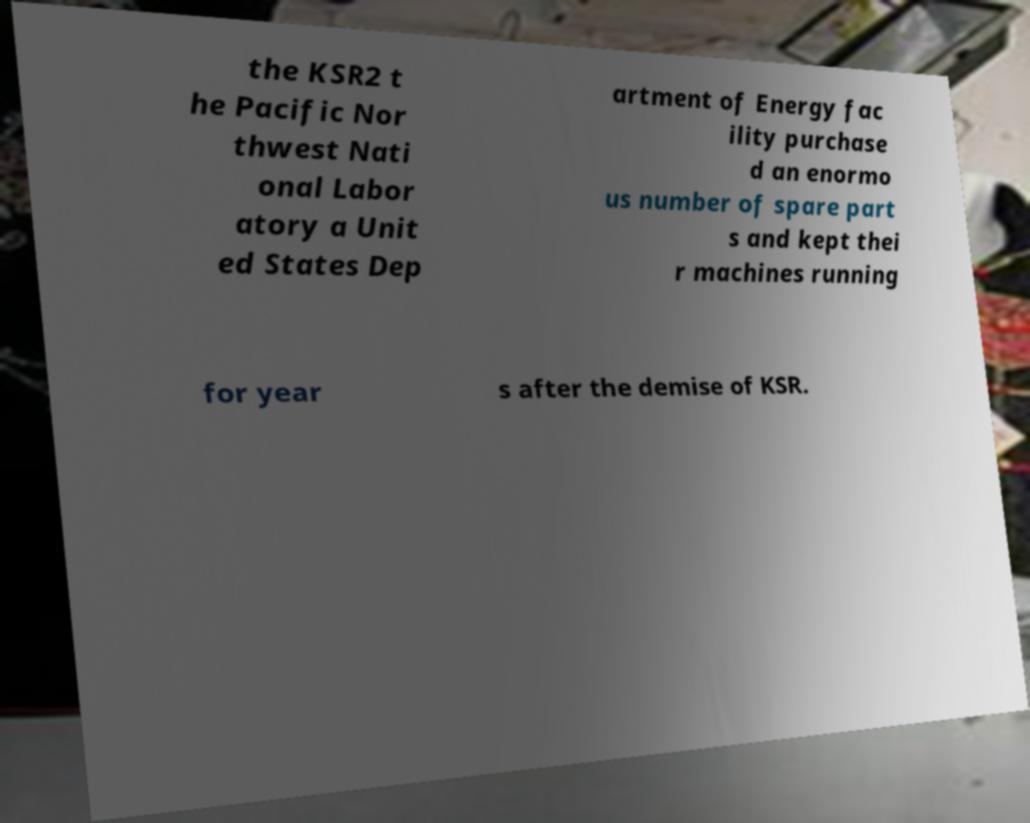Please read and relay the text visible in this image. What does it say? the KSR2 t he Pacific Nor thwest Nati onal Labor atory a Unit ed States Dep artment of Energy fac ility purchase d an enormo us number of spare part s and kept thei r machines running for year s after the demise of KSR. 